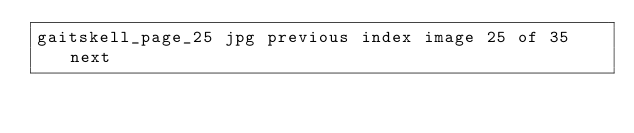Convert code to text. <code><loc_0><loc_0><loc_500><loc_500><_HTML_>gaitskell_page_25 jpg previous index image 25 of 35 next
</code> 